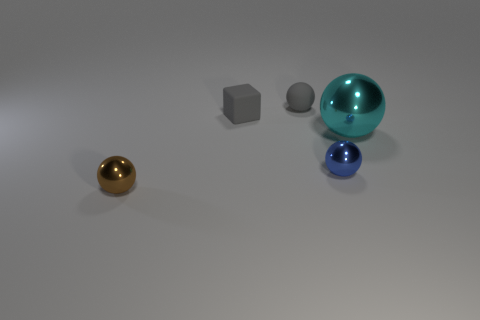There is a gray thing that is the same material as the gray ball; what is its shape?
Provide a succinct answer. Cube. There is a tiny ball that is behind the large shiny ball; is it the same color as the shiny object left of the blue metal object?
Offer a very short reply. No. How many balls are in front of the big ball and to the left of the tiny blue sphere?
Your answer should be very brief. 1. What size is the blue object that is the same material as the large sphere?
Offer a very short reply. Small. The gray rubber ball has what size?
Give a very brief answer. Small. What is the material of the small gray ball?
Offer a terse response. Rubber. There is a gray thing that is in front of the gray matte sphere; is it the same size as the blue metal ball?
Provide a short and direct response. Yes. How many objects are big yellow metallic cubes or brown metal spheres?
Your answer should be compact. 1. The small object that is the same color as the small matte ball is what shape?
Offer a terse response. Cube. There is a sphere that is both left of the tiny blue object and behind the tiny blue ball; how big is it?
Offer a terse response. Small. 